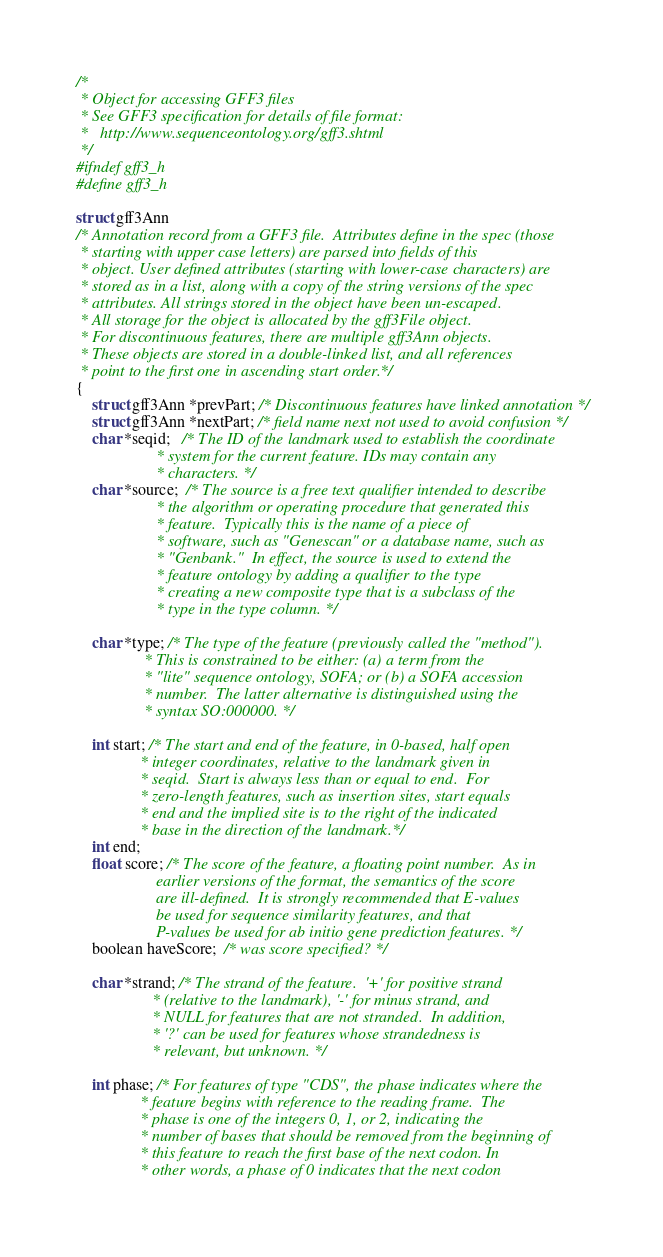<code> <loc_0><loc_0><loc_500><loc_500><_C_>/*
 * Object for accessing GFF3 files
 * See GFF3 specification for details of file format:
 *   http://www.sequenceontology.org/gff3.shtml
 */
#ifndef gff3_h
#define gff3_h

struct gff3Ann
/* Annotation record from a GFF3 file.  Attributes define in the spec (those
 * starting with upper case letters) are parsed into fields of this
 * object. User defined attributes (starting with lower-case characters) are
 * stored as in a list, along with a copy of the string versions of the spec
 * attributes. All strings stored in the object have been un-escaped.
 * All storage for the object is allocated by the gff3File object.
 * For discontinuous features, there are multiple gff3Ann objects.
 * These objects are stored in a double-linked list, and all references
 * point to the first one in ascending start order.*/
{
    struct gff3Ann *prevPart; /* Discontinuous features have linked annotation */
    struct gff3Ann *nextPart; /* field name next not used to avoid confusion */
    char *seqid;   /* The ID of the landmark used to establish the coordinate
                    * system for the current feature. IDs may contain any
                    * characters. */
    char *source;  /* The source is a free text qualifier intended to describe
                    * the algorithm or operating procedure that generated this
                    * feature.  Typically this is the name of a piece of
                    * software, such as "Genescan" or a database name, such as
                    * "Genbank."  In effect, the source is used to extend the
                    * feature ontology by adding a qualifier to the type
                    * creating a new composite type that is a subclass of the
                    * type in the type column. */

    char *type; /* The type of the feature (previously called the "method").
                 * This is constrained to be either: (a) a term from the
                 * "lite" sequence ontology, SOFA; or (b) a SOFA accession
                 * number.  The latter alternative is distinguished using the
                 * syntax SO:000000. */

    int start; /* The start and end of the feature, in 0-based, half open
                * integer coordinates, relative to the landmark given in
                * seqid.  Start is always less than or equal to end.  For
                * zero-length features, such as insertion sites, start equals
                * end and the implied site is to the right of the indicated
                * base in the direction of the landmark.*/
    int end;
    float score; /* The score of the feature, a floating point number.  As in
                    earlier versions of the format, the semantics of the score
                    are ill-defined.  It is strongly recommended that E-values
                    be used for sequence similarity features, and that
                    P-values be used for ab initio gene prediction features. */
    boolean haveScore;  /* was score specified? */

    char *strand; /* The strand of the feature.  '+' for positive strand
                   * (relative to the landmark), '-' for minus strand, and
                   * NULL for features that are not stranded.  In addition,
                   * '?' can be used for features whose strandedness is
                   * relevant, but unknown. */

    int phase; /* For features of type "CDS", the phase indicates where the
                * feature begins with reference to the reading frame.  The
                * phase is one of the integers 0, 1, or 2, indicating the
                * number of bases that should be removed from the beginning of
                * this feature to reach the first base of the next codon. In
                * other words, a phase of 0 indicates that the next codon</code> 